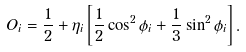<formula> <loc_0><loc_0><loc_500><loc_500>O _ { i } = \frac { 1 } { 2 } + \eta _ { i } \left [ \frac { 1 } { 2 } \cos ^ { 2 } \phi _ { i } + \frac { 1 } { 3 } \sin ^ { 2 } \phi _ { i } \right ] .</formula> 